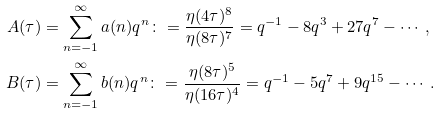<formula> <loc_0><loc_0><loc_500><loc_500>A ( \tau ) & = \sum _ { n = - 1 } ^ { \infty } a ( n ) q ^ { n } \colon = \frac { \eta ( 4 \tau ) ^ { 8 } } { \eta ( 8 \tau ) ^ { 7 } } = q ^ { - 1 } - 8 q ^ { 3 } + 2 7 q ^ { 7 } - \cdots , \\ B ( \tau ) & = \sum _ { n = - 1 } ^ { \infty } b ( n ) q ^ { n } \colon = \frac { \eta ( 8 \tau ) ^ { 5 } } { \eta ( 1 6 \tau ) ^ { 4 } } = q ^ { - 1 } - 5 q ^ { 7 } + 9 q ^ { 1 5 } - \cdots .</formula> 